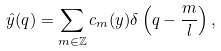<formula> <loc_0><loc_0><loc_500><loc_500>\hat { y } ( q ) = \sum _ { m \in \mathbb { Z } } c _ { m } ( y ) \delta \left ( q - \frac { m } { l } \right ) ,</formula> 